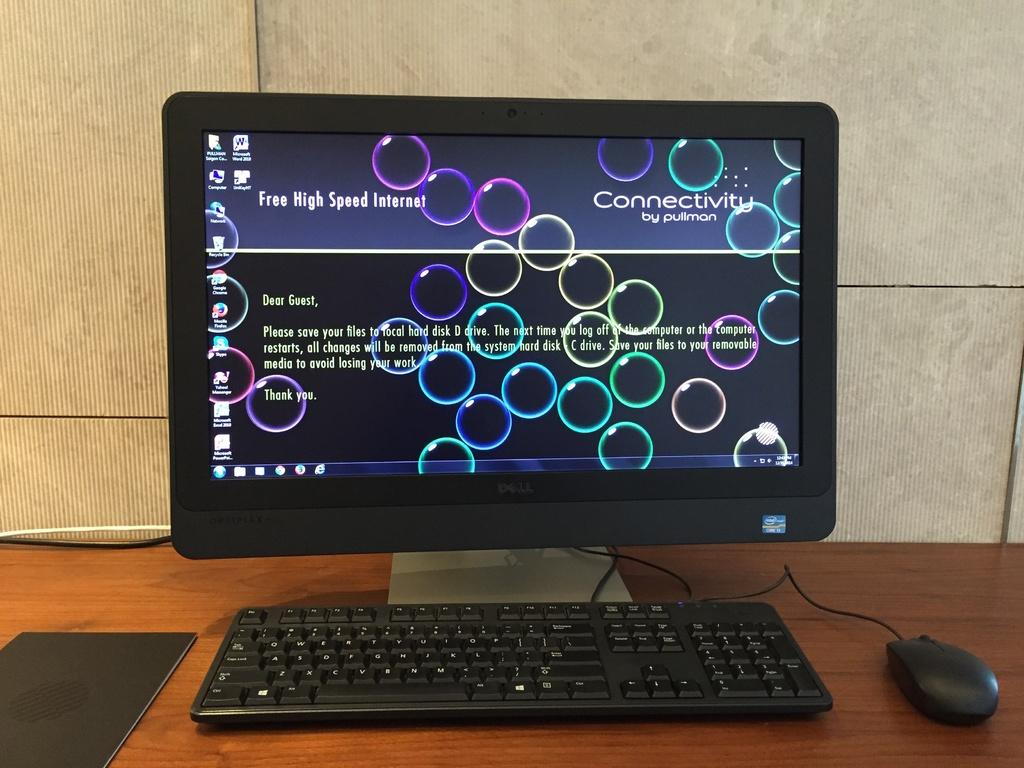<image>
Render a clear and concise summary of the photo. A computer shows a background screen of colorful bubbles and the word "Connectivity" in the upper right corner. 